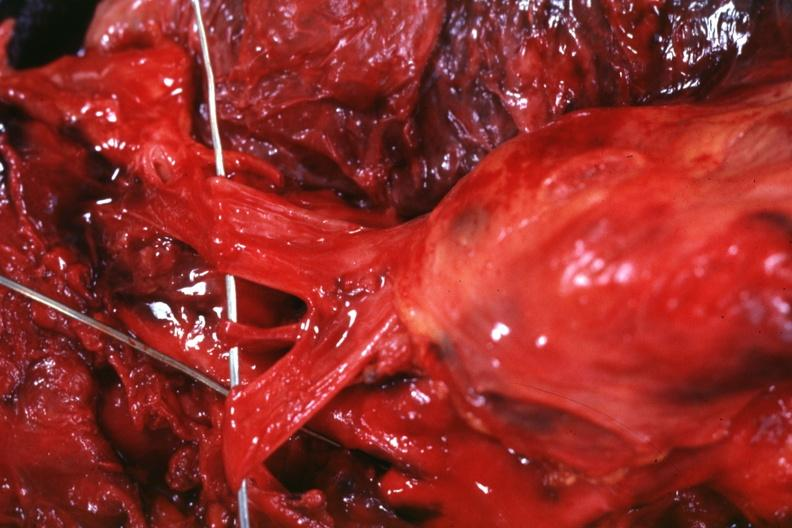s thymus present?
Answer the question using a single word or phrase. Yes 